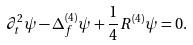Convert formula to latex. <formula><loc_0><loc_0><loc_500><loc_500>\partial _ { t } ^ { 2 } \psi - \Delta _ { f } ^ { ( 4 ) } \psi + \frac { 1 } { 4 } R ^ { ( 4 ) } \psi = 0 .</formula> 